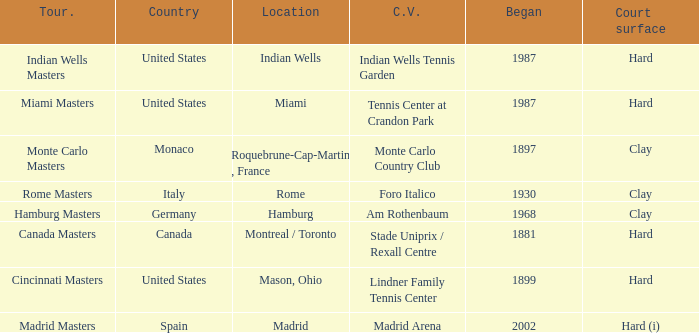What is the number of tournaments held at the lindner family tennis center as their present venue? 1.0. 